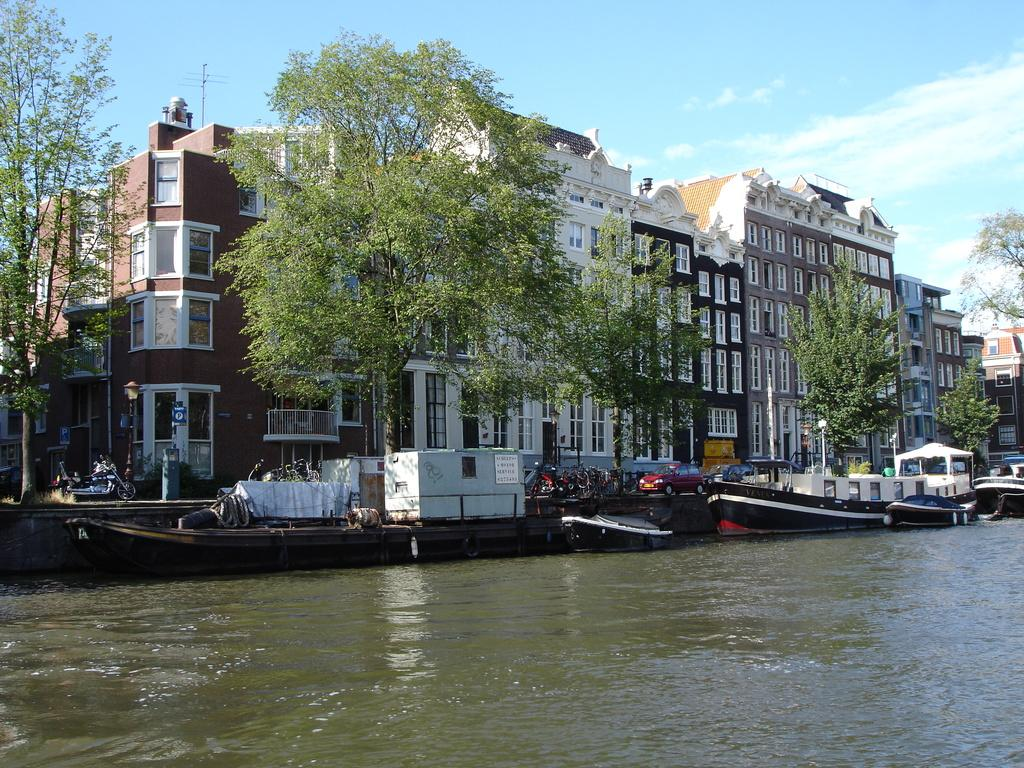What is on the water in the image? There are boats on the water in the image. What else can be seen in the image besides the boats? There are vehicles, buildings, trees, and the sky visible in the image. Can you describe the types of vehicles in the image? The provided facts do not specify the types of vehicles in the image. What is the background of the image? The sky is visible in the background of the image. What time of day is it in the image, as indicated by the presence of a pin or dime? There is no pin or dime present in the image, and therefore no indication of the time of day. 